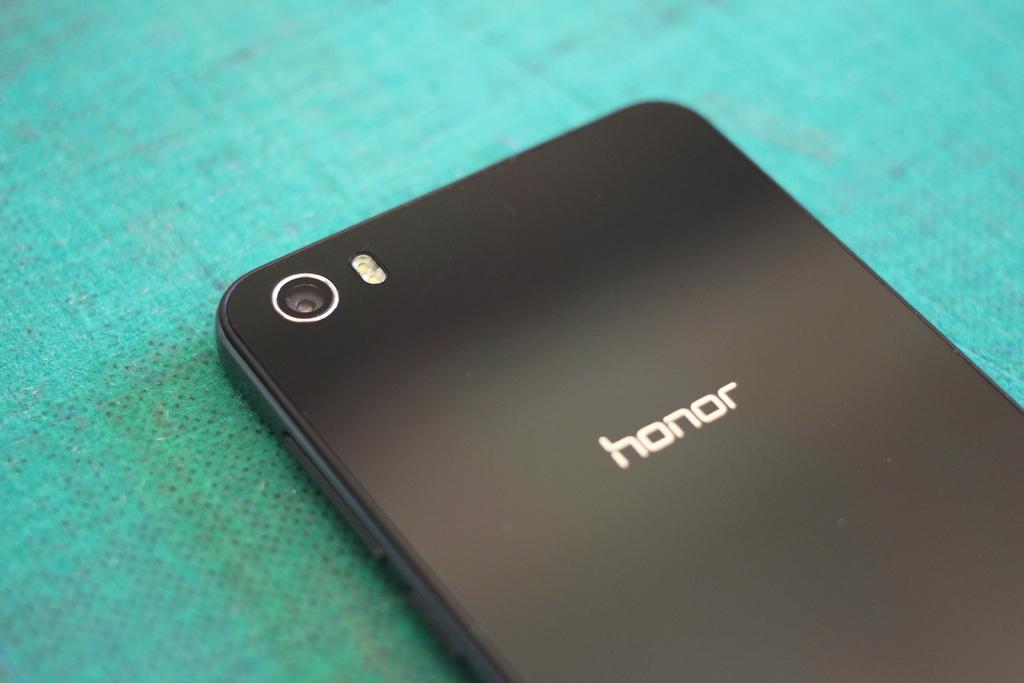What does the phone say?
Provide a short and direct response. Honor. What is this brand of phone?
Your response must be concise. Honor. 